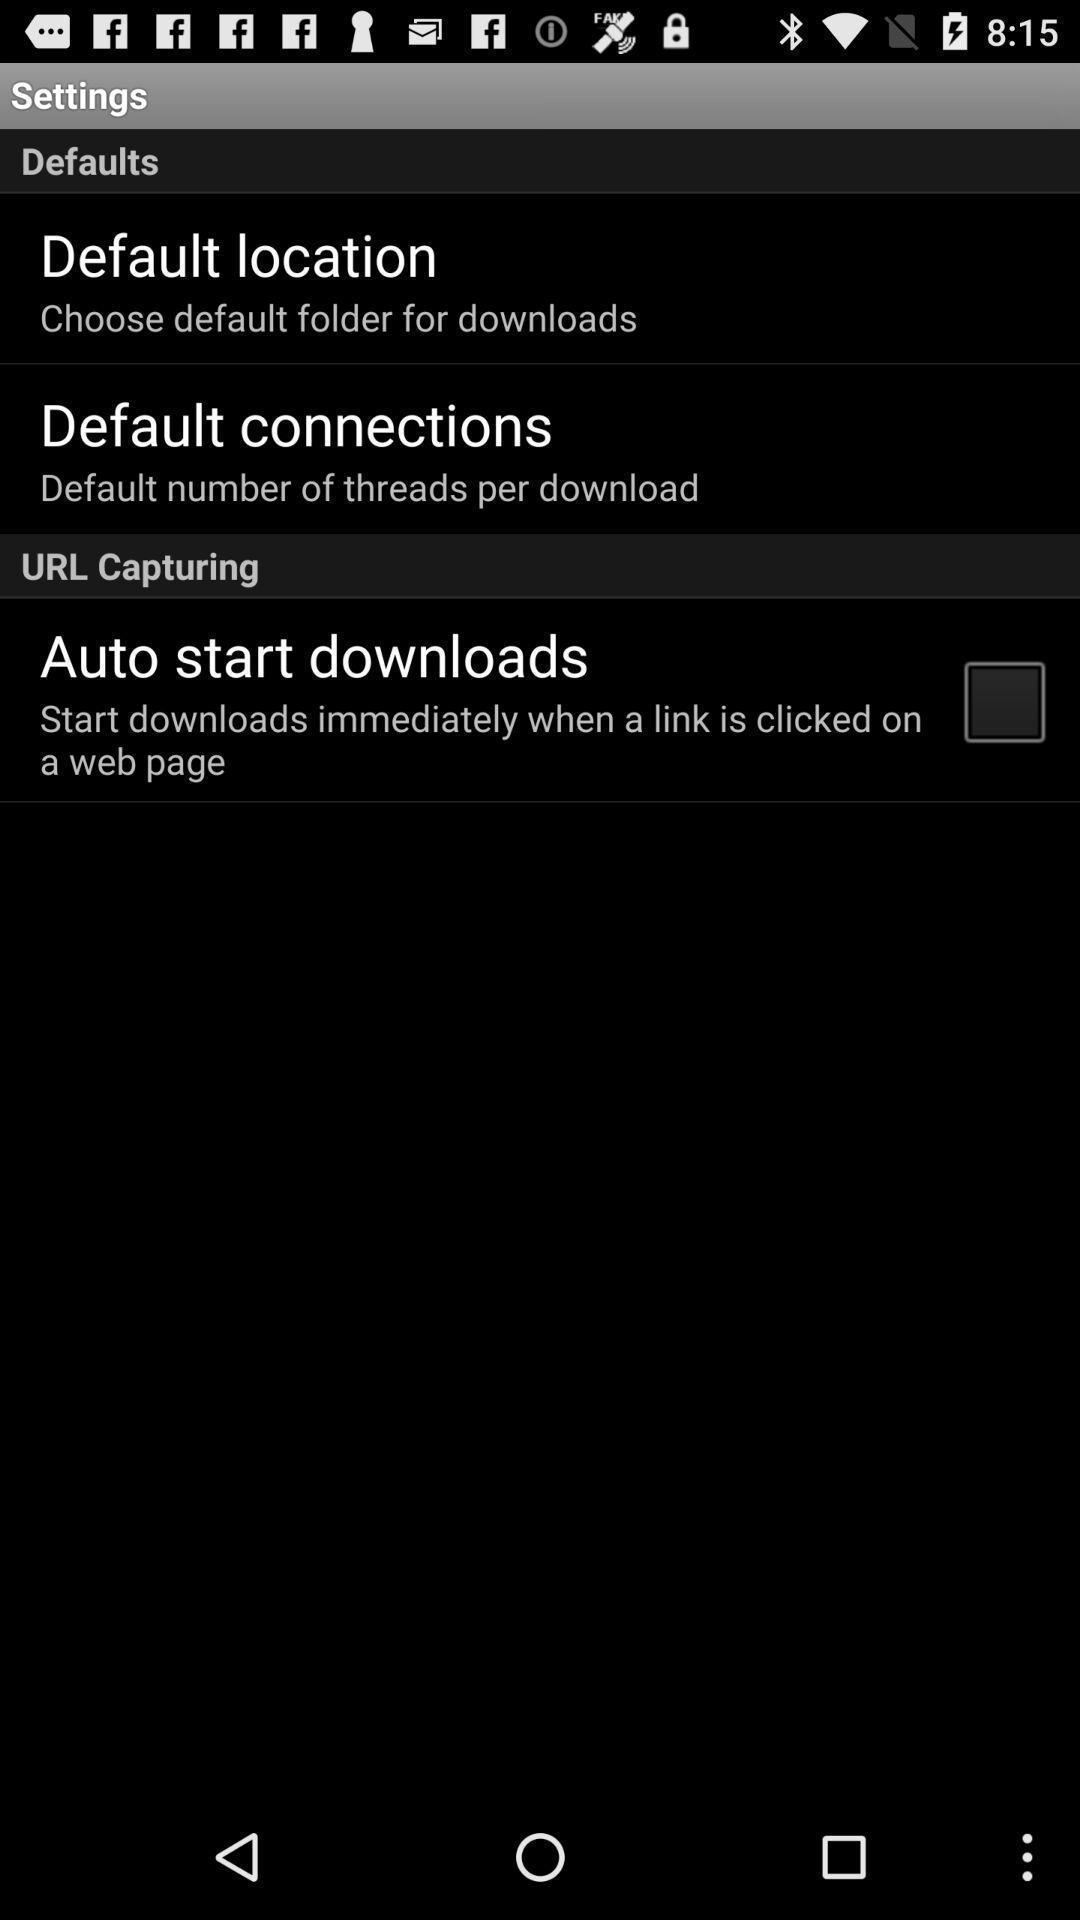Summarize the main components in this picture. Settings page with various other options. 